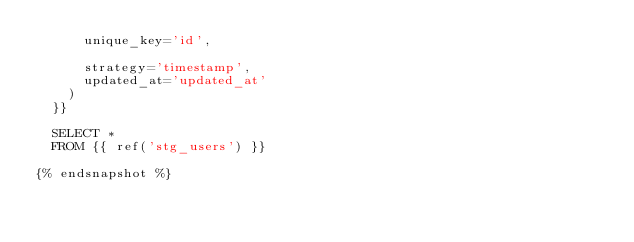<code> <loc_0><loc_0><loc_500><loc_500><_SQL_>      unique_key='id',

      strategy='timestamp',
      updated_at='updated_at'
    )
  }}

  SELECT * 
  FROM {{ ref('stg_users') }}

{% endsnapshot %}</code> 